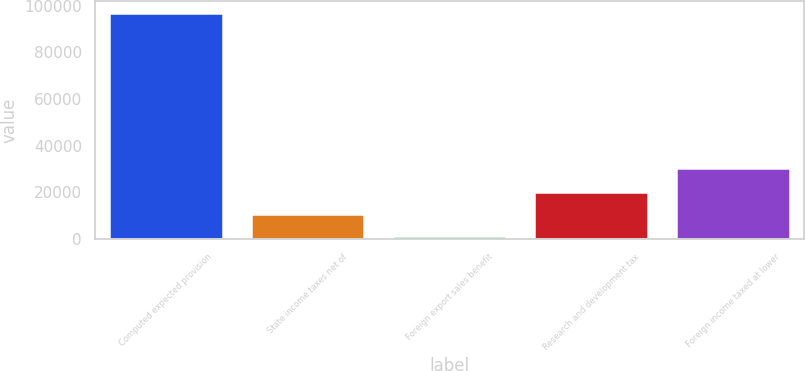Convert chart to OTSL. <chart><loc_0><loc_0><loc_500><loc_500><bar_chart><fcel>Computed expected provision<fcel>State income taxes net of<fcel>Foreign export sales benefit<fcel>Research and development tax<fcel>Foreign income taxed at lower<nl><fcel>97044<fcel>10704.3<fcel>1111<fcel>20297.6<fcel>30438<nl></chart> 